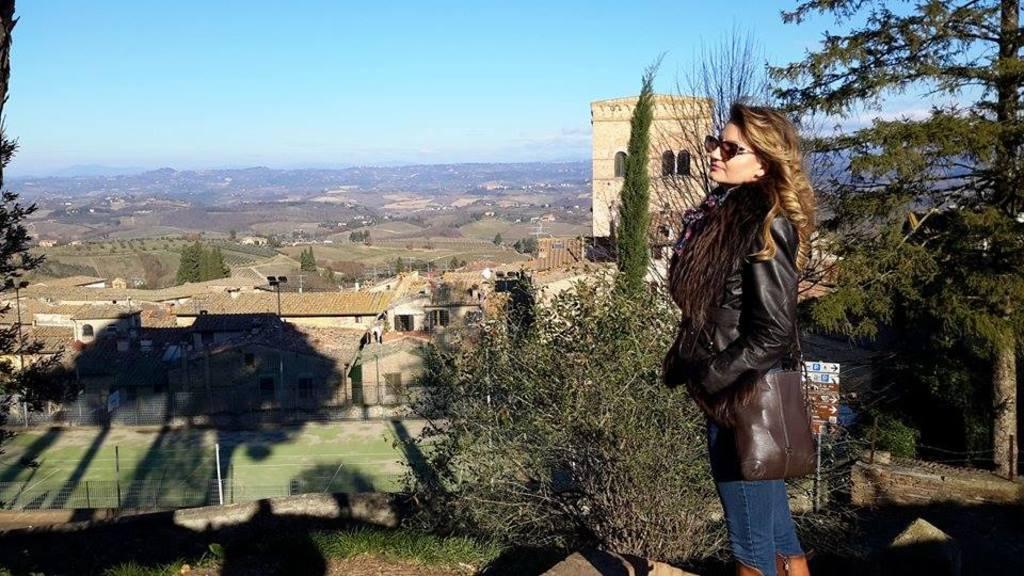How would you summarize this image in a sentence or two? In this picture, we can see a lady carrying some object, we can see the ground with grass, trees, plants, and some objects, we can see buildings, poles, lights, and we can see the sky. 